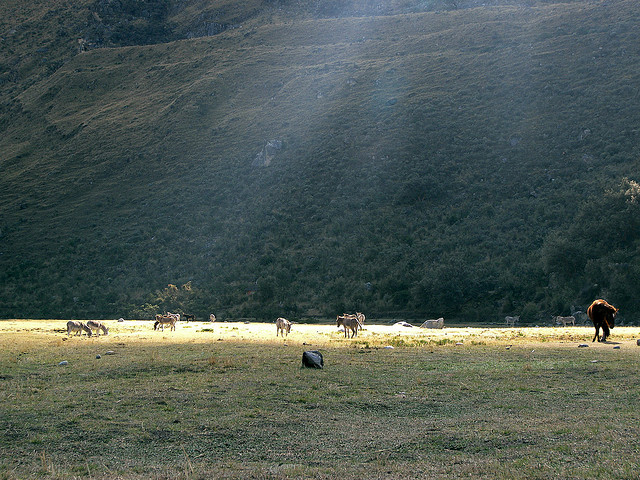What time of day does it seem to be in this image? Judging by the lighting and the length of the shadows, it seems to be either early morning or late afternoon, times when the sun is lower in the sky and creates a warm, diffuse light. Does the image give any signs of human activity? There is no direct evidence of people in the image, such as buildings or paths. However, the presence of horses suggests some level of human interaction, as horses are typically domesticated animals. 